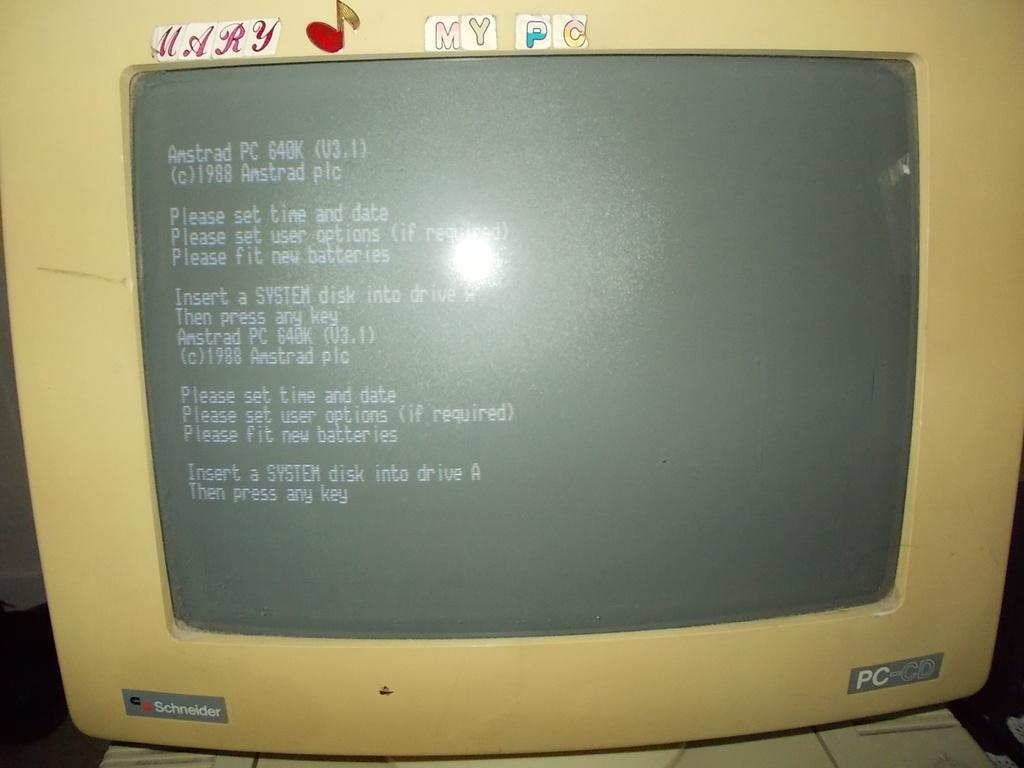Provide a one-sentence caption for the provided image. an old PC-CD computer monitor made by Schneider. 